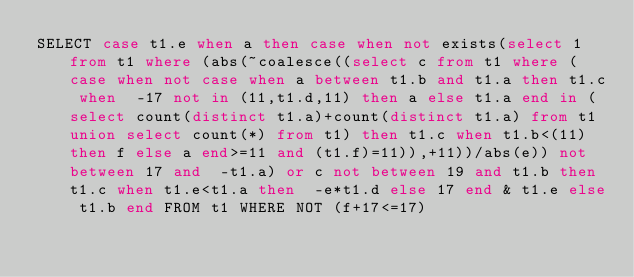Convert code to text. <code><loc_0><loc_0><loc_500><loc_500><_SQL_>SELECT case t1.e when a then case when not exists(select 1 from t1 where (abs(~coalesce((select c from t1 where (case when not case when a between t1.b and t1.a then t1.c when  -17 not in (11,t1.d,11) then a else t1.a end in (select count(distinct t1.a)+count(distinct t1.a) from t1 union select count(*) from t1) then t1.c when t1.b<(11) then f else a end>=11 and (t1.f)=11)),+11))/abs(e)) not between 17 and  -t1.a) or c not between 19 and t1.b then t1.c when t1.e<t1.a then  -e*t1.d else 17 end & t1.e else t1.b end FROM t1 WHERE NOT (f+17<=17)</code> 